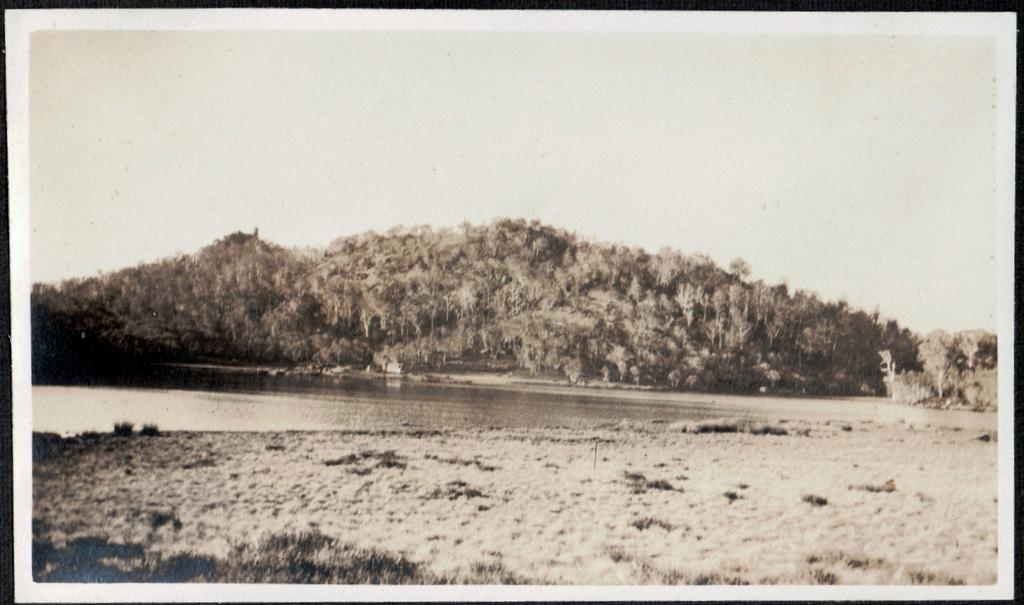What type of natural environment is depicted in the image? The image contains grass and water, suggesting a natural setting. What can be seen in the background of the image? There are trees and the sky visible in the background of the image. Can you describe the water in the image? The facts provided do not specify the type or characteristics of the water. What type of vest is being worn by the tree in the image? There is no vest present in the image, as trees do not wear clothing. 